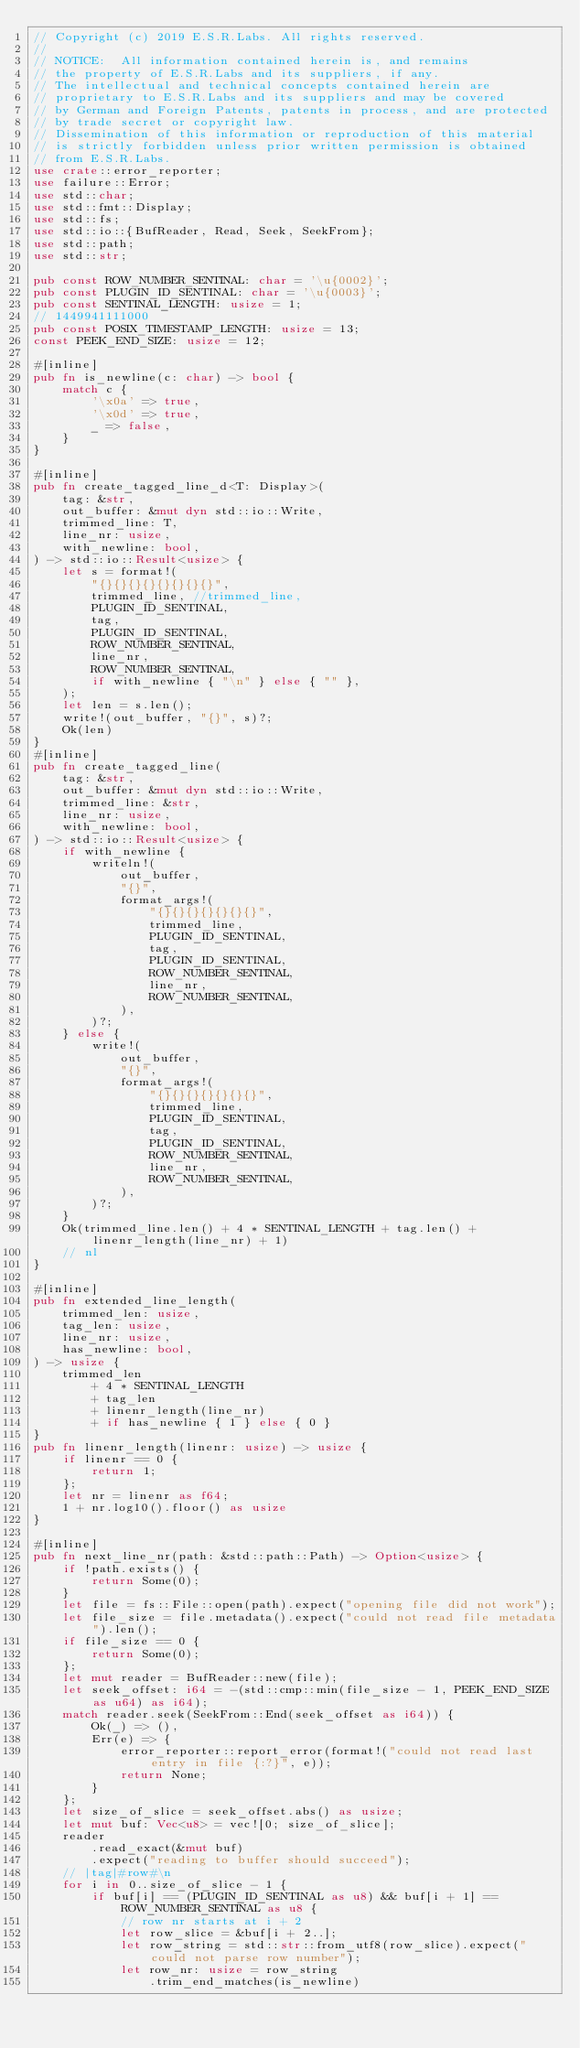<code> <loc_0><loc_0><loc_500><loc_500><_Rust_>// Copyright (c) 2019 E.S.R.Labs. All rights reserved.
//
// NOTICE:  All information contained herein is, and remains
// the property of E.S.R.Labs and its suppliers, if any.
// The intellectual and technical concepts contained herein are
// proprietary to E.S.R.Labs and its suppliers and may be covered
// by German and Foreign Patents, patents in process, and are protected
// by trade secret or copyright law.
// Dissemination of this information or reproduction of this material
// is strictly forbidden unless prior written permission is obtained
// from E.S.R.Labs.
use crate::error_reporter;
use failure::Error;
use std::char;
use std::fmt::Display;
use std::fs;
use std::io::{BufReader, Read, Seek, SeekFrom};
use std::path;
use std::str;

pub const ROW_NUMBER_SENTINAL: char = '\u{0002}';
pub const PLUGIN_ID_SENTINAL: char = '\u{0003}';
pub const SENTINAL_LENGTH: usize = 1;
// 1449941111000
pub const POSIX_TIMESTAMP_LENGTH: usize = 13;
const PEEK_END_SIZE: usize = 12;

#[inline]
pub fn is_newline(c: char) -> bool {
    match c {
        '\x0a' => true,
        '\x0d' => true,
        _ => false,
    }
}

#[inline]
pub fn create_tagged_line_d<T: Display>(
    tag: &str,
    out_buffer: &mut dyn std::io::Write,
    trimmed_line: T,
    line_nr: usize,
    with_newline: bool,
) -> std::io::Result<usize> {
    let s = format!(
        "{}{}{}{}{}{}{}{}",
        trimmed_line, //trimmed_line,
        PLUGIN_ID_SENTINAL,
        tag,
        PLUGIN_ID_SENTINAL,
        ROW_NUMBER_SENTINAL,
        line_nr,
        ROW_NUMBER_SENTINAL,
        if with_newline { "\n" } else { "" },
    );
    let len = s.len();
    write!(out_buffer, "{}", s)?;
    Ok(len)
}
#[inline]
pub fn create_tagged_line(
    tag: &str,
    out_buffer: &mut dyn std::io::Write,
    trimmed_line: &str,
    line_nr: usize,
    with_newline: bool,
) -> std::io::Result<usize> {
    if with_newline {
        writeln!(
            out_buffer,
            "{}",
            format_args!(
                "{}{}{}{}{}{}{}",
                trimmed_line,
                PLUGIN_ID_SENTINAL,
                tag,
                PLUGIN_ID_SENTINAL,
                ROW_NUMBER_SENTINAL,
                line_nr,
                ROW_NUMBER_SENTINAL,
            ),
        )?;
    } else {
        write!(
            out_buffer,
            "{}",
            format_args!(
                "{}{}{}{}{}{}{}",
                trimmed_line,
                PLUGIN_ID_SENTINAL,
                tag,
                PLUGIN_ID_SENTINAL,
                ROW_NUMBER_SENTINAL,
                line_nr,
                ROW_NUMBER_SENTINAL,
            ),
        )?;
    }
    Ok(trimmed_line.len() + 4 * SENTINAL_LENGTH + tag.len() + linenr_length(line_nr) + 1)
    // nl
}

#[inline]
pub fn extended_line_length(
    trimmed_len: usize,
    tag_len: usize,
    line_nr: usize,
    has_newline: bool,
) -> usize {
    trimmed_len
        + 4 * SENTINAL_LENGTH
        + tag_len
        + linenr_length(line_nr)
        + if has_newline { 1 } else { 0 }
}
pub fn linenr_length(linenr: usize) -> usize {
    if linenr == 0 {
        return 1;
    };
    let nr = linenr as f64;
    1 + nr.log10().floor() as usize
}

#[inline]
pub fn next_line_nr(path: &std::path::Path) -> Option<usize> {
    if !path.exists() {
        return Some(0);
    }
    let file = fs::File::open(path).expect("opening file did not work");
    let file_size = file.metadata().expect("could not read file metadata").len();
    if file_size == 0 {
        return Some(0);
    };
    let mut reader = BufReader::new(file);
    let seek_offset: i64 = -(std::cmp::min(file_size - 1, PEEK_END_SIZE as u64) as i64);
    match reader.seek(SeekFrom::End(seek_offset as i64)) {
        Ok(_) => (),
        Err(e) => {
            error_reporter::report_error(format!("could not read last entry in file {:?}", e));
            return None;
        }
    };
    let size_of_slice = seek_offset.abs() as usize;
    let mut buf: Vec<u8> = vec![0; size_of_slice];
    reader
        .read_exact(&mut buf)
        .expect("reading to buffer should succeed");
    // |tag|#row#\n
    for i in 0..size_of_slice - 1 {
        if buf[i] == (PLUGIN_ID_SENTINAL as u8) && buf[i + 1] == ROW_NUMBER_SENTINAL as u8 {
            // row nr starts at i + 2
            let row_slice = &buf[i + 2..];
            let row_string = std::str::from_utf8(row_slice).expect("could not parse row number");
            let row_nr: usize = row_string
                .trim_end_matches(is_newline)</code> 